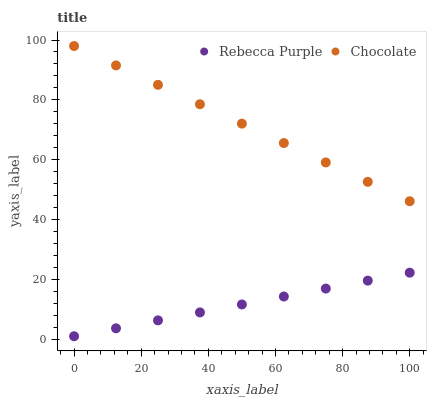Does Rebecca Purple have the minimum area under the curve?
Answer yes or no. Yes. Does Chocolate have the maximum area under the curve?
Answer yes or no. Yes. Does Chocolate have the minimum area under the curve?
Answer yes or no. No. Is Rebecca Purple the smoothest?
Answer yes or no. Yes. Is Chocolate the roughest?
Answer yes or no. Yes. Is Chocolate the smoothest?
Answer yes or no. No. Does Rebecca Purple have the lowest value?
Answer yes or no. Yes. Does Chocolate have the lowest value?
Answer yes or no. No. Does Chocolate have the highest value?
Answer yes or no. Yes. Is Rebecca Purple less than Chocolate?
Answer yes or no. Yes. Is Chocolate greater than Rebecca Purple?
Answer yes or no. Yes. Does Rebecca Purple intersect Chocolate?
Answer yes or no. No. 